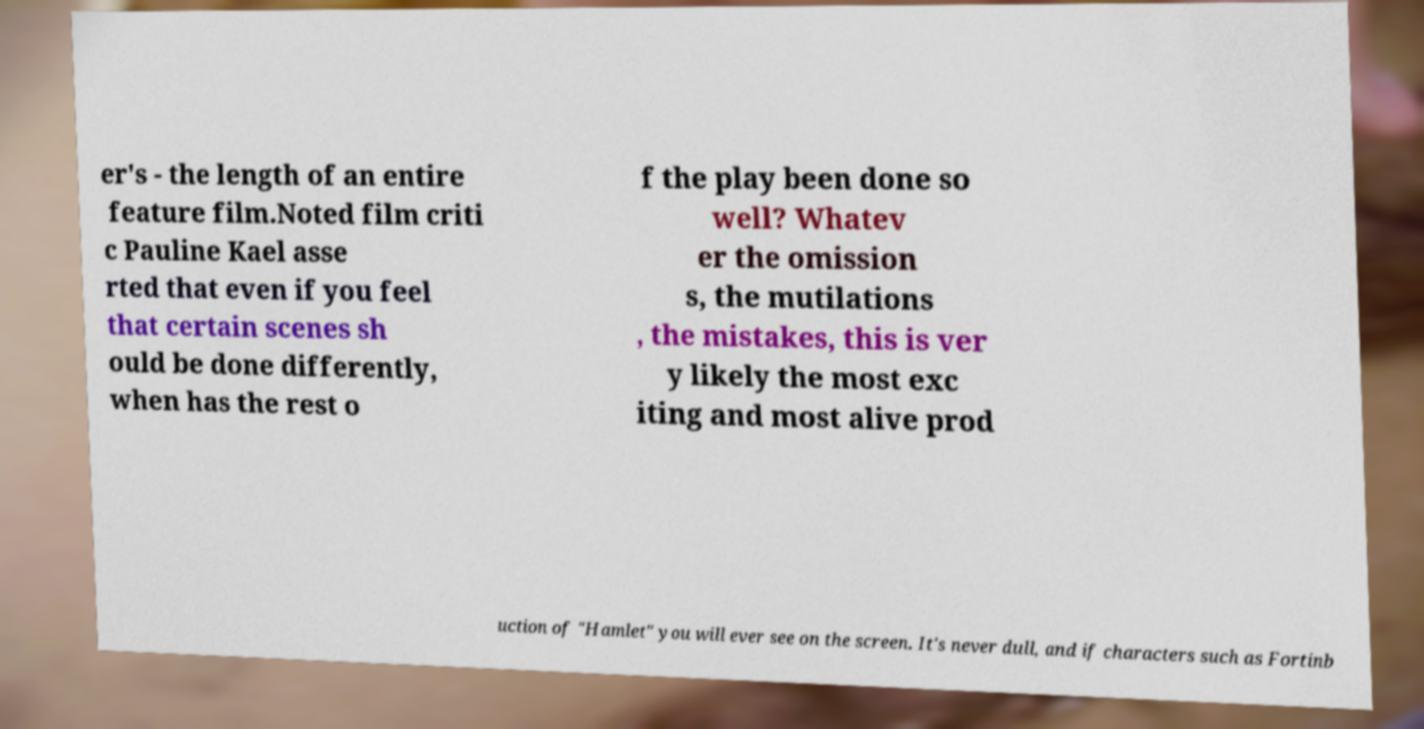What messages or text are displayed in this image? I need them in a readable, typed format. er's - the length of an entire feature film.Noted film criti c Pauline Kael asse rted that even if you feel that certain scenes sh ould be done differently, when has the rest o f the play been done so well? Whatev er the omission s, the mutilations , the mistakes, this is ver y likely the most exc iting and most alive prod uction of "Hamlet" you will ever see on the screen. It's never dull, and if characters such as Fortinb 